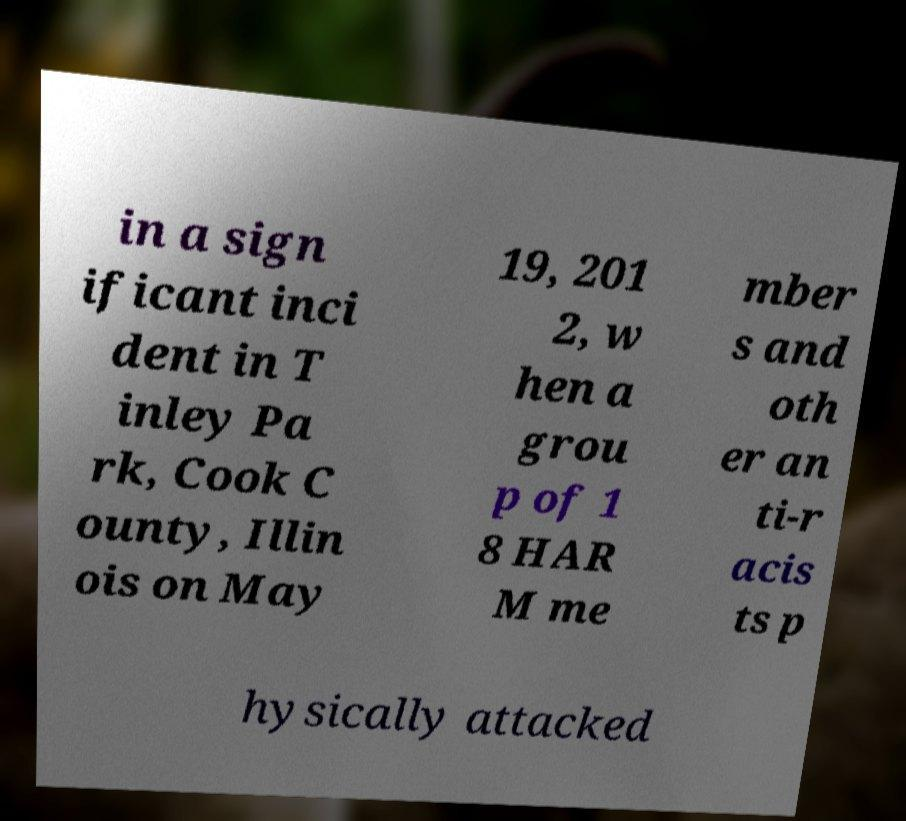Can you accurately transcribe the text from the provided image for me? in a sign ificant inci dent in T inley Pa rk, Cook C ounty, Illin ois on May 19, 201 2, w hen a grou p of 1 8 HAR M me mber s and oth er an ti-r acis ts p hysically attacked 